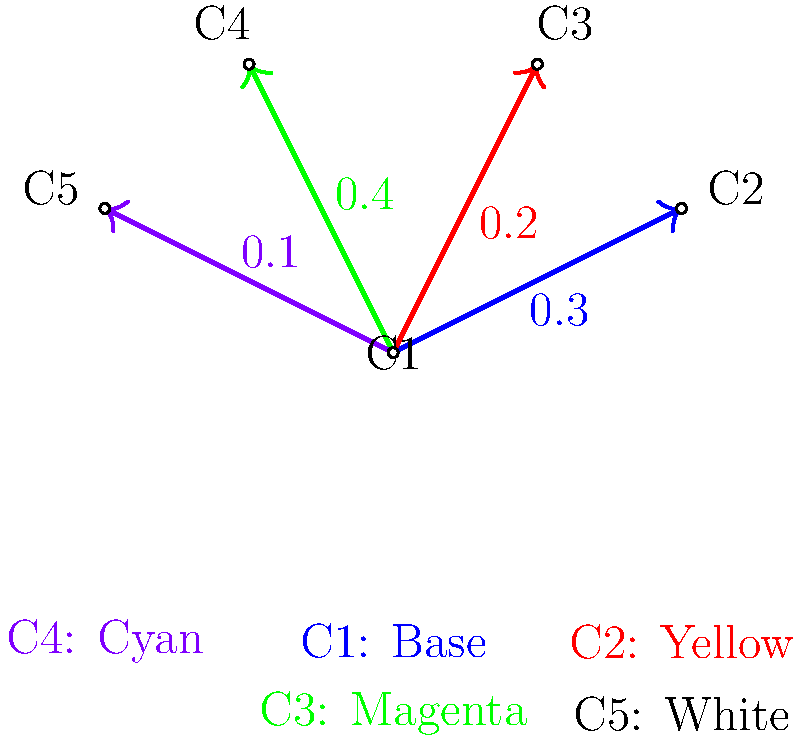As you're preparing for your next avant-garde exhibition, you're experimenting with a unique color mixing technique. The weighted graph represents the ratios of different colors to be mixed with a base color (C1) to create a custom palette. If you start with 100 units of the base color, how many units of the final mixture will you have after adding all the colors according to the given ratios? Let's break this down step-by-step:

1) We start with 100 units of the base color (C1).

2) The graph shows the ratios for mixing other colors with the base:
   - C2 (Yellow): 0.3
   - C3 (Magenta): 0.2
   - C4 (Cyan): 0.4
   - C5 (White): 0.1

3) To calculate the amount of each color to add:
   - Yellow: $100 \times 0.3 = 30$ units
   - Magenta: $100 \times 0.2 = 20$ units
   - Cyan: $100 \times 0.4 = 40$ units
   - White: $100 \times 0.1 = 10$ units

4) Now, let's sum up all the components:
   $100 + 30 + 20 + 40 + 10 = 200$

Therefore, after mixing all the colors according to the given ratios, you will have 200 units of the final mixture.
Answer: 200 units 